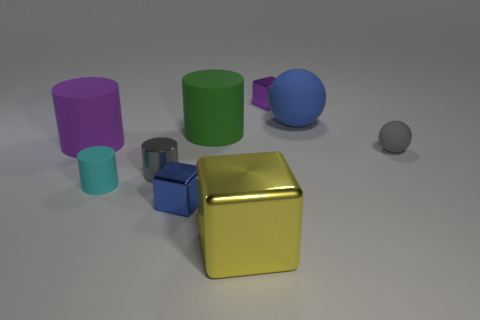Is there a pattern to the arrangement of the objects? The objects seem to be arranged without a precise pattern. They are placed at various distances and angles from one another, which may indicate a random or casual placement rather than a deliberate pattern. 